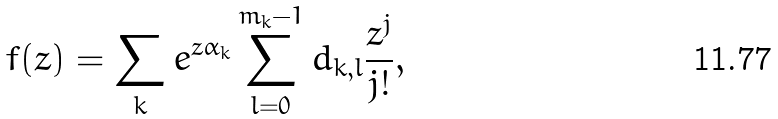<formula> <loc_0><loc_0><loc_500><loc_500>f ( z ) = \sum _ { k } e ^ { z \alpha _ { k } } \sum _ { l = 0 } ^ { m _ { k } - 1 } d _ { k , l } \frac { z ^ { j } } { j ! } ,</formula> 